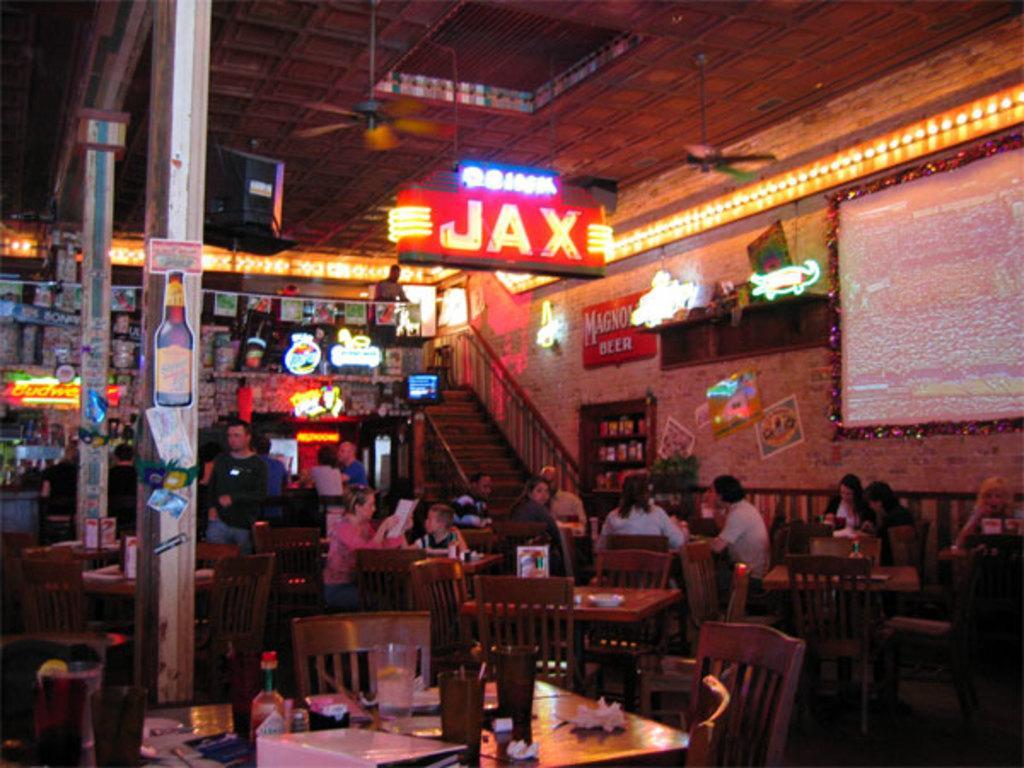Could you give a brief overview of what you see in this image? In the image in the center we can see few people were sitting on the chairs around the tables. On the tables,we can see jars,bottles,tissue papers,plate and few other objects. In the background there is a wall,roof,board,staircase,banners,sign boards,tables,chairs,photo frames and few other objects. 